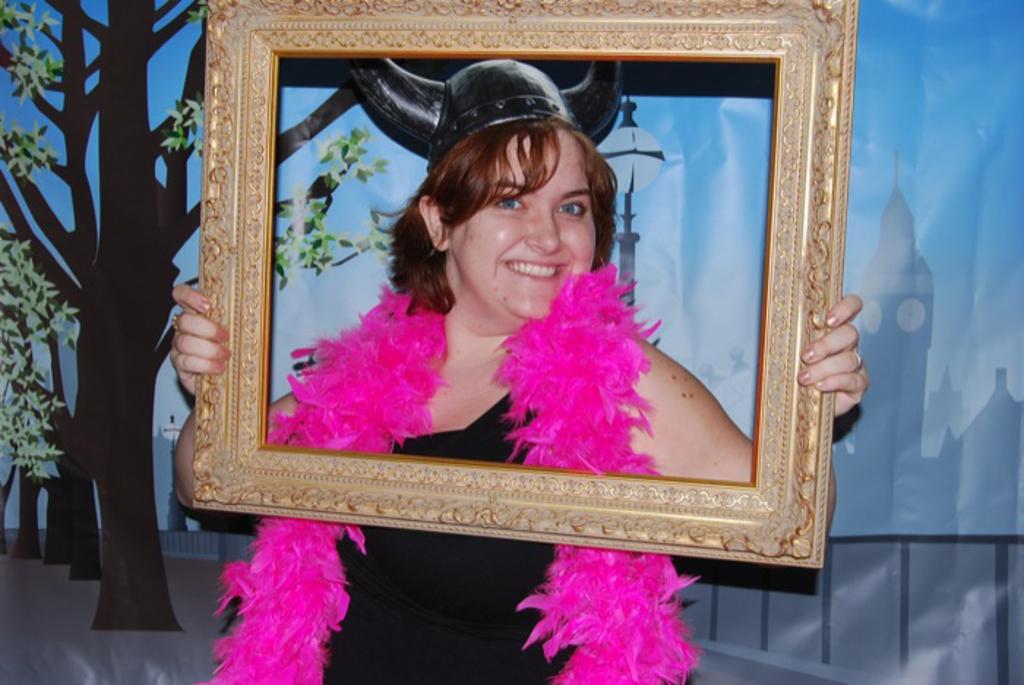Describe this image in one or two sentences. In this image I can see a woman in the front and I can see she is holding a frame. I can see she is wearing black colour dress, black helmet and on her shoulders I can see a pink colour thing. I can also see smile on her face and in the background I can see depiction of trees and of few buildings. 